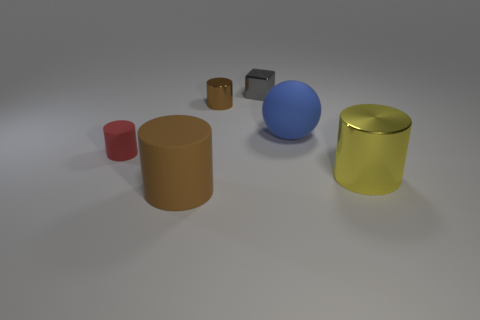Add 1 big cubes. How many objects exist? 7 Subtract all spheres. How many objects are left? 5 Subtract 0 red spheres. How many objects are left? 6 Subtract all tiny gray shiny cubes. Subtract all small yellow rubber cubes. How many objects are left? 5 Add 6 metallic cubes. How many metallic cubes are left? 7 Add 2 gray metal balls. How many gray metal balls exist? 2 